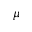Convert formula to latex. <formula><loc_0><loc_0><loc_500><loc_500>\mu</formula> 